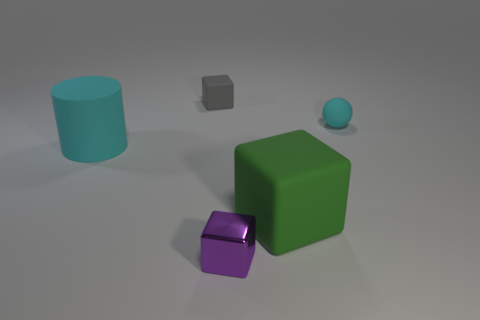Subtract all large cubes. How many cubes are left? 2 Subtract 1 spheres. How many spheres are left? 0 Add 5 small objects. How many objects exist? 10 Subtract all gray cubes. How many cubes are left? 2 Subtract all purple cubes. Subtract all blue spheres. How many cubes are left? 2 Subtract all gray cubes. Subtract all tiny cubes. How many objects are left? 2 Add 1 tiny cyan matte things. How many tiny cyan matte things are left? 2 Add 1 big objects. How many big objects exist? 3 Subtract 0 blue cylinders. How many objects are left? 5 Subtract all cubes. How many objects are left? 2 